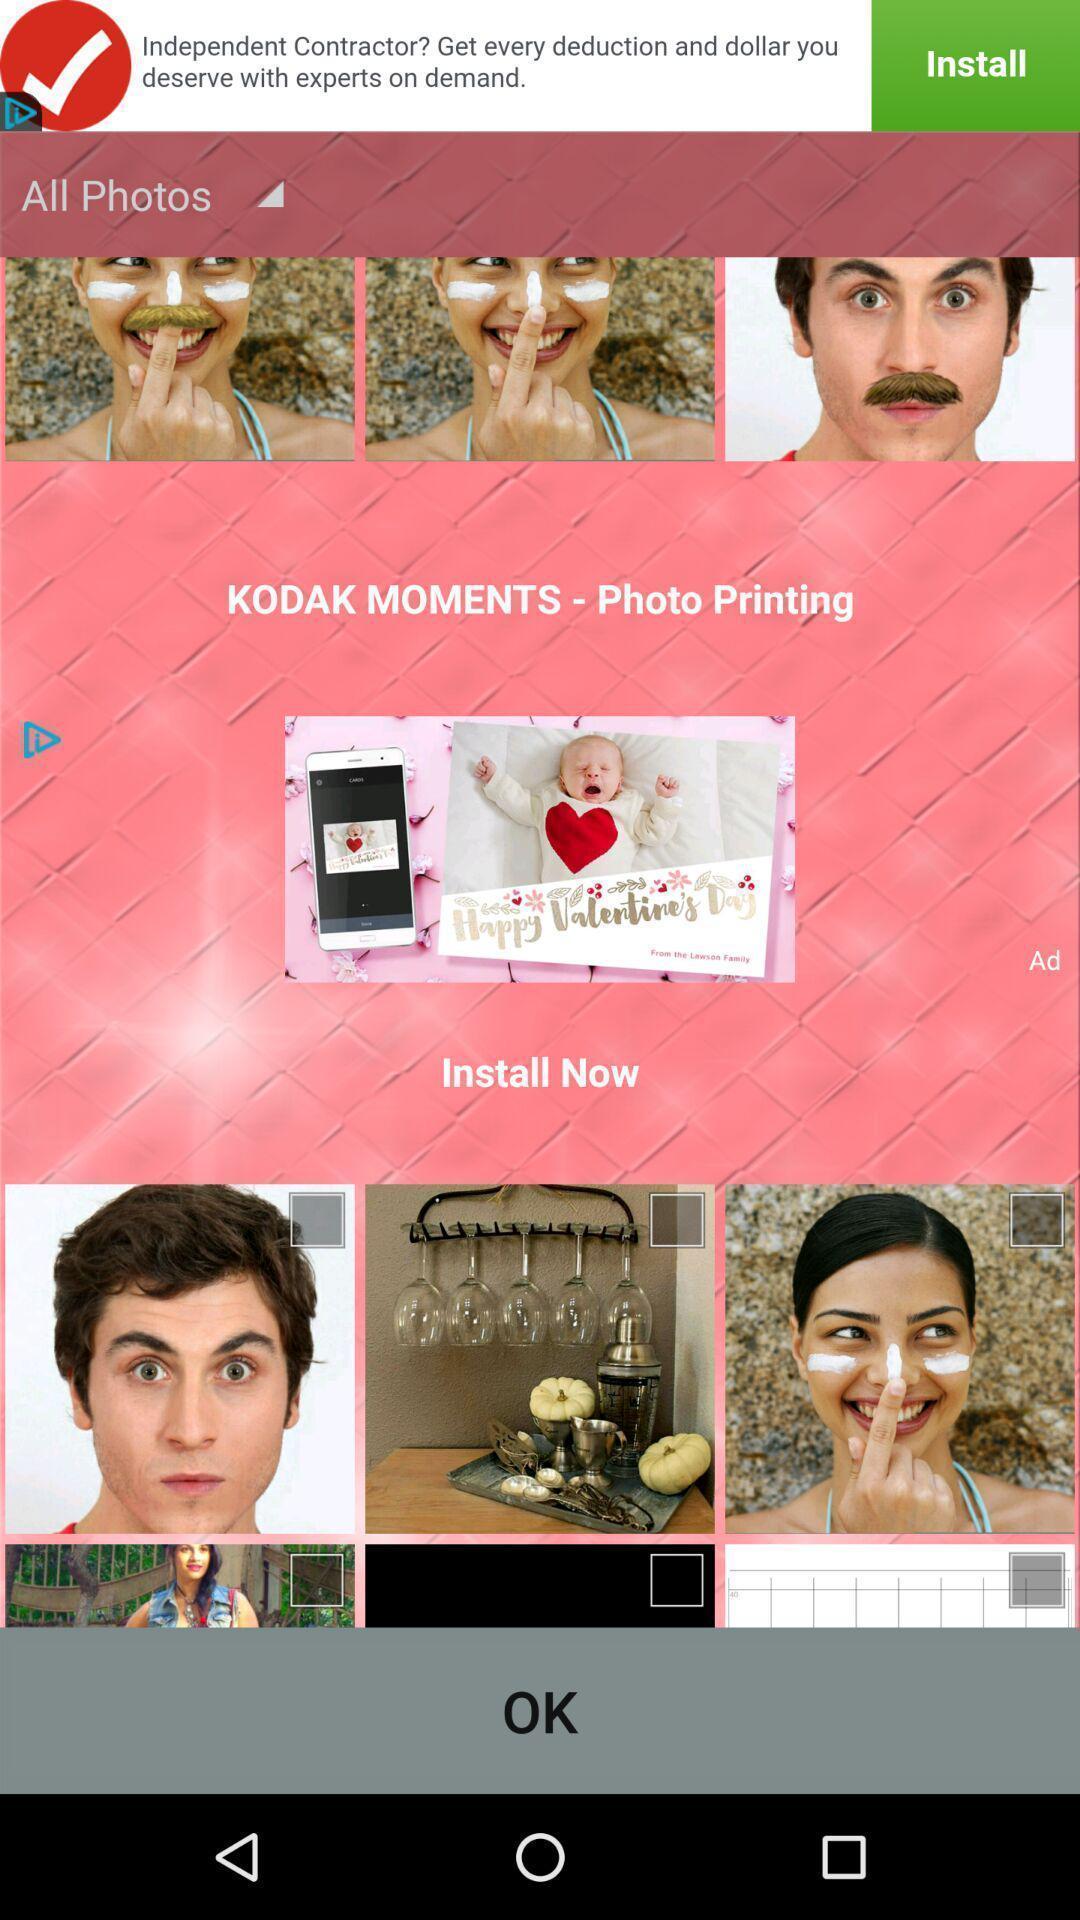Tell me about the visual elements in this screen capture. Page showing photo editing application. 